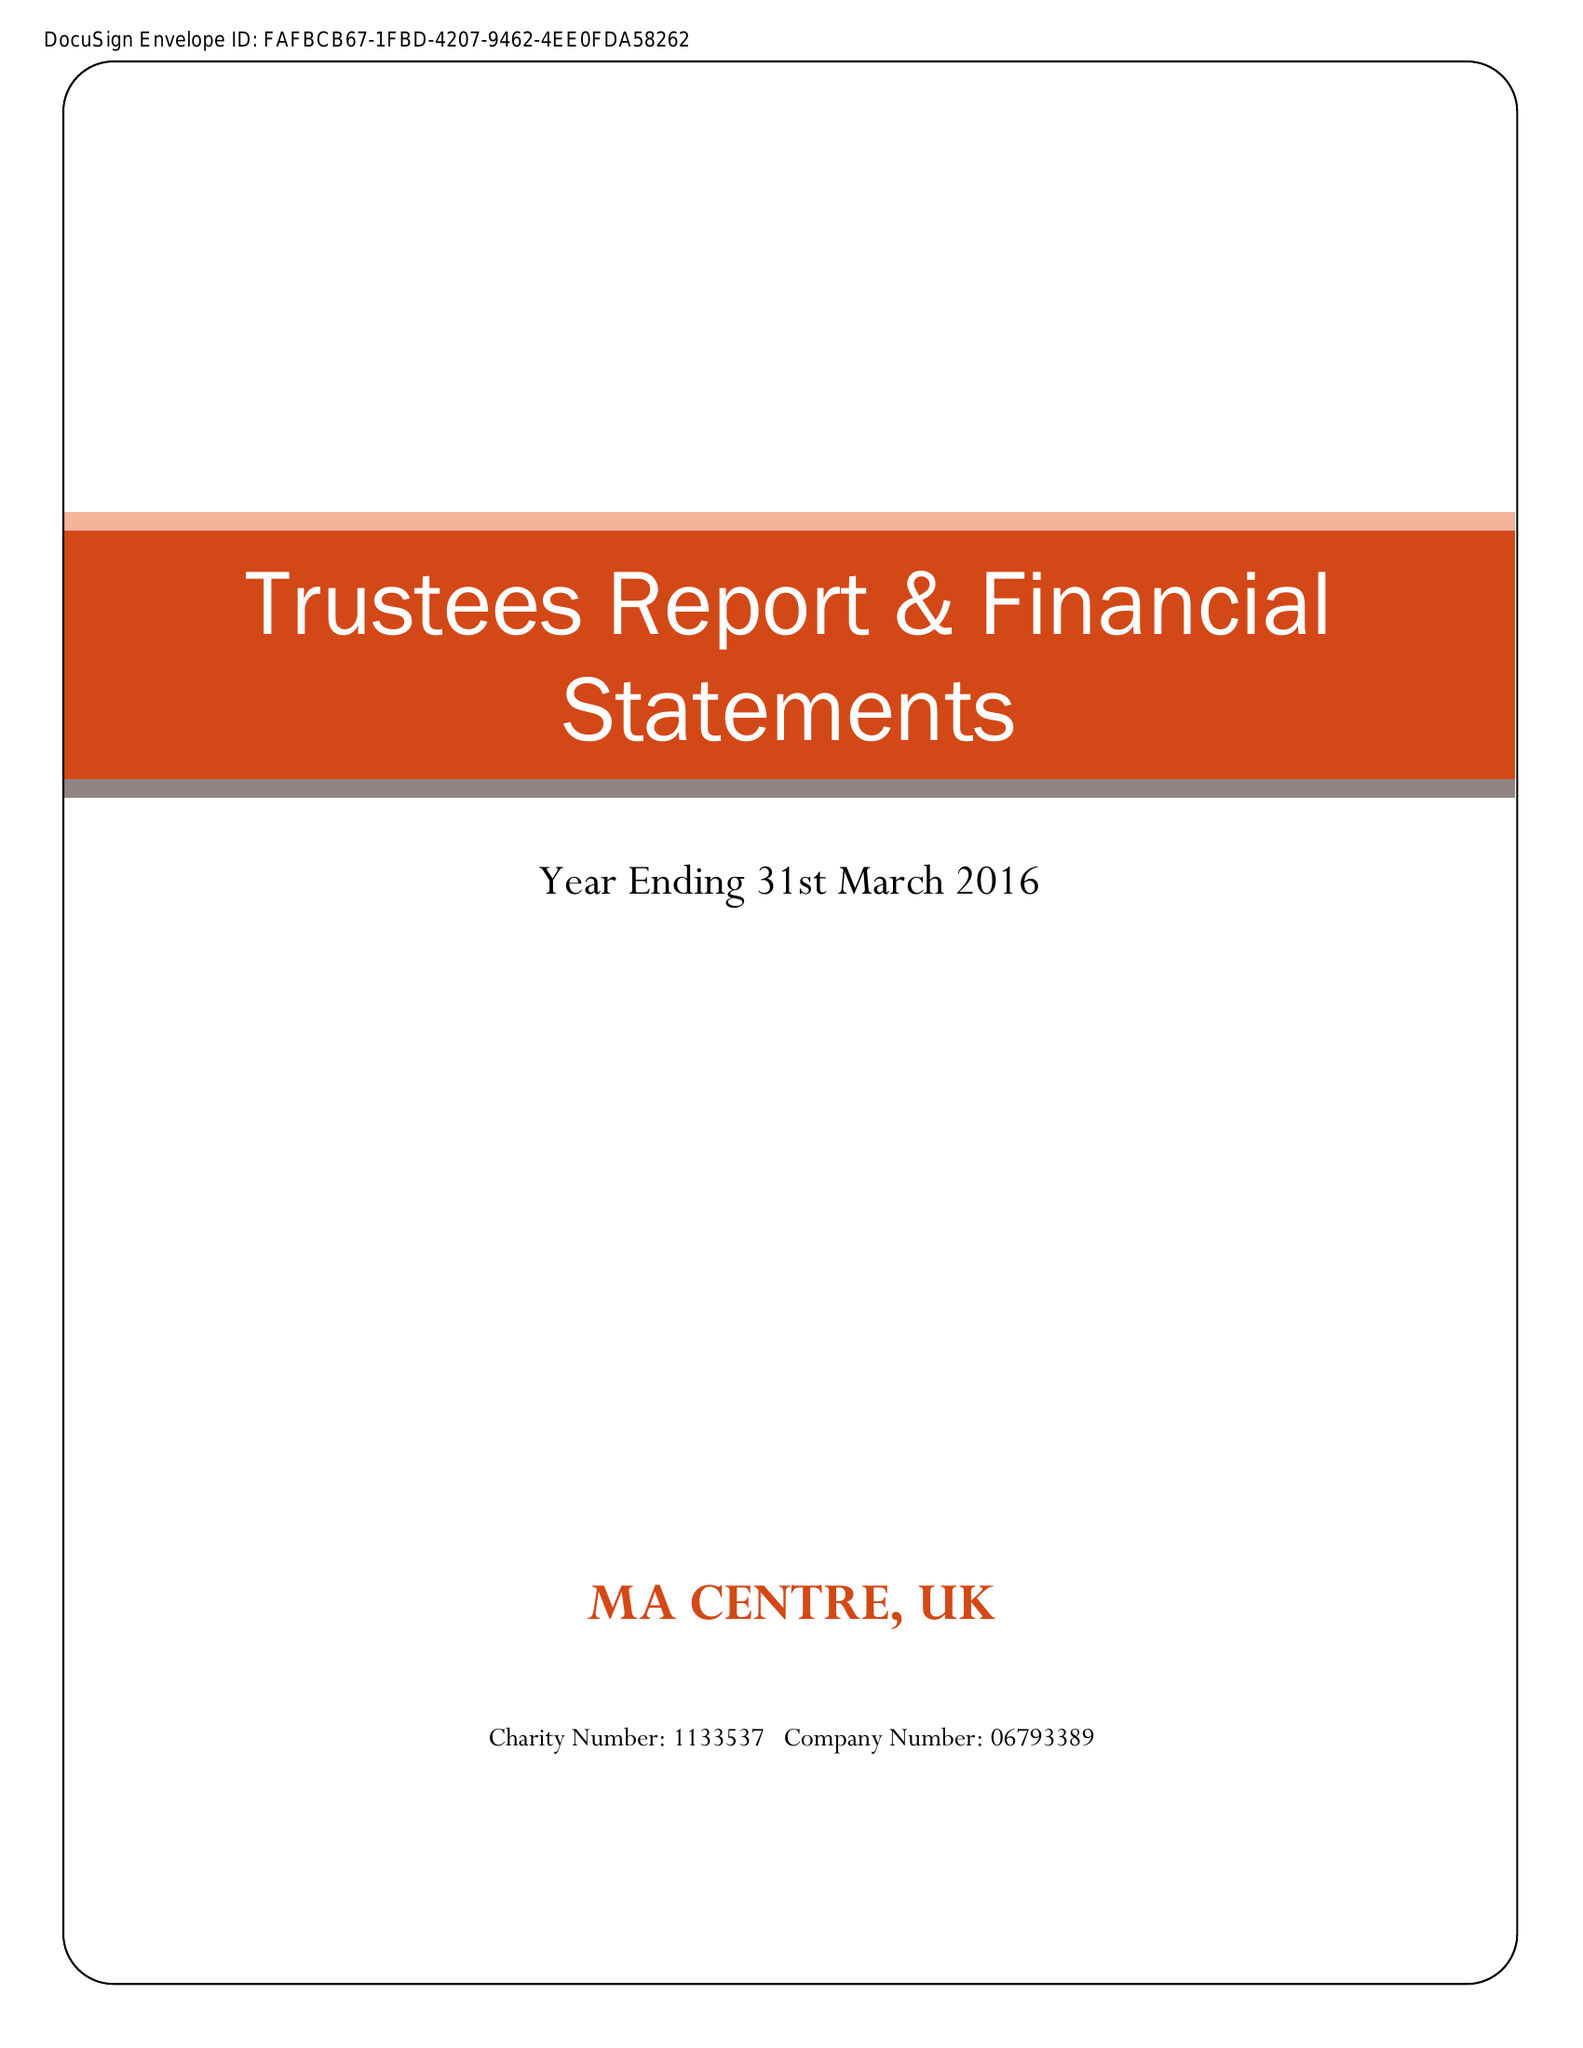What is the value for the address__postcode?
Answer the question using a single word or phrase. BR2 9BE 